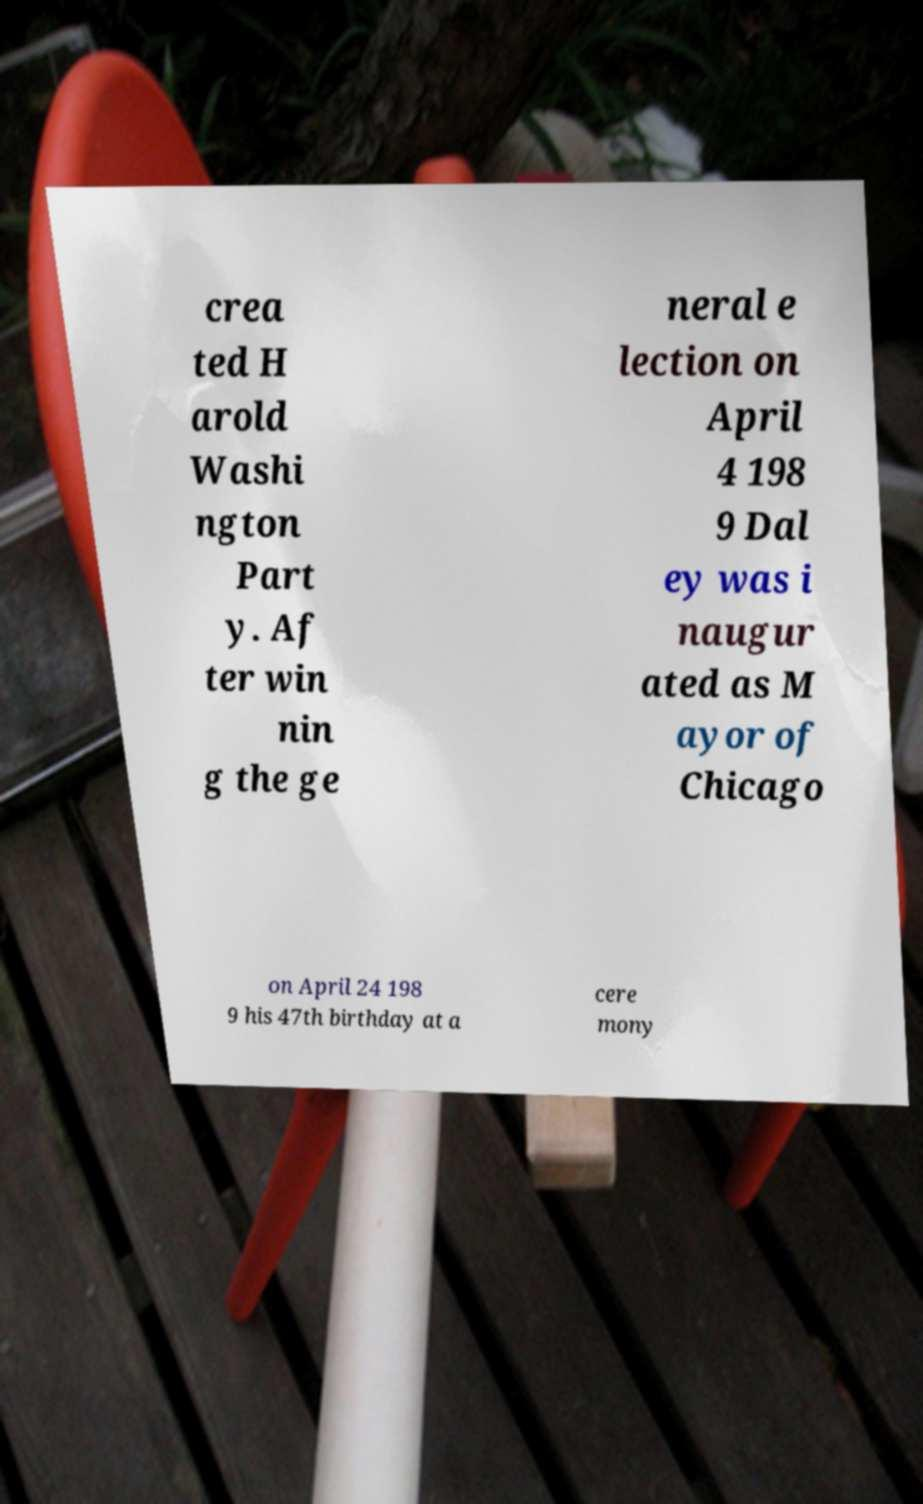Could you assist in decoding the text presented in this image and type it out clearly? crea ted H arold Washi ngton Part y. Af ter win nin g the ge neral e lection on April 4 198 9 Dal ey was i naugur ated as M ayor of Chicago on April 24 198 9 his 47th birthday at a cere mony 